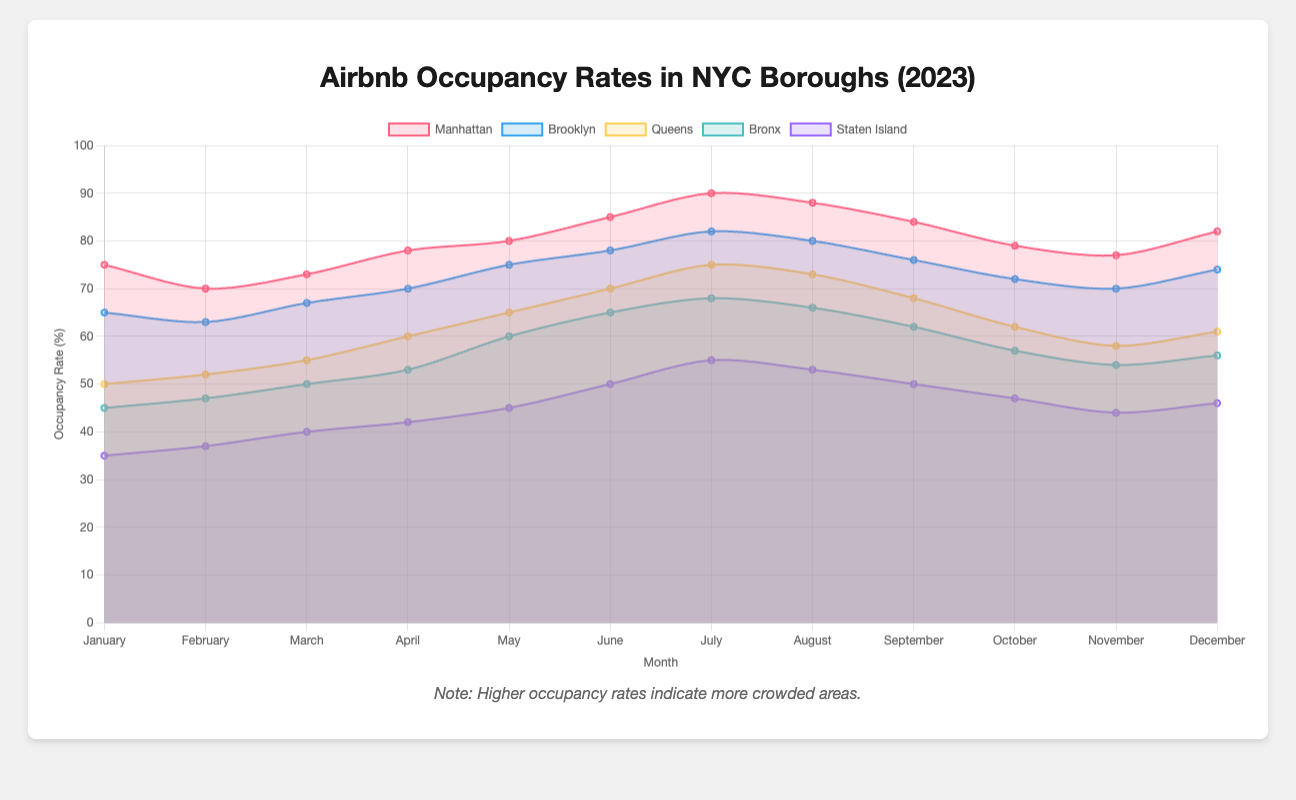What is the title of the chart? The title of the chart is usually displayed at the top. Here it is stated as "Airbnb Occupancy Rates in NYC Boroughs (2023)".
Answer: "Airbnb Occupancy Rates in NYC Boroughs (2023)" In which month does Manhattan have the highest occupancy rate? From the data, we can see that Manhattan's occupancy rate is the highest in July at 90%.
Answer: July How do the occupancy rates of Brooklyn in July compare to those in August? Brooklyn's occupancy rate in July is 82%, while in August it is 80%. Therefore, July has a higher occupancy rate.
Answer: July What is the overall trend for Queens' occupancy rates from January to December? The chart shows that Queens' occupancy rates steadily increase from January (50%) to July (75%), then gradually decrease towards December (61%).
Answer: Increasing then decreasing Which borough has the lowest average occupancy rate over the year? To find the average occupancy rate for each borough over the year, sum the monthly rates and divide by 12. The borough with the lowest sum/average rate will be the answer. Here, Staten Island has the lowest rates, so it will likely have the lowest average. Sum all rates for Staten Island (35, 37, 40, 42, 45, 50, 55, 53, 50, 47, 44, 46) which total 544, then divide by 12 to get the average which is around 45.33.
Answer: Staten Island Which borough has the highest increase in occupancy rate between January and July? By comparing the occupancy rates in January and July for each borough, we see the differences:
- Manhattan: 90 - 75 = 15
- Brooklyn: 82 - 65 = 17
- Queens: 75 - 50 = 25
- Bronx: 68 - 45 = 23
- Staten Island: 55 - 35 = 20
Queens has the highest increase (from 50% to 75%), which is 25%.
Answer: Queens In which month does the Bronx experience the lowest occupancy rate? From the data for the Bronx, the lowest occupancy rate is in January at 45%.
Answer: January Which borough has the smallest variation in occupancy rates over the year? By comparing the range (difference between max and min) of occupancy rates for each borough:
- Manhattan: 90 - 70 = 20
- Brooklyn: 82 - 63 = 19
- Queens: 75 - 50 = 25
- Bronx: 68 - 45 = 23
- Staten Island: 55 - 35 = 20
Brooklyn has the smallest variation, with a range of 19%.
Answer: Brooklyn How do the occupancy rates in Staten Island for May and June compare? From the data, Staten Island has an occupancy rate of 45% in May and 50% in June. Therefore, June has a higher occupancy rate.
Answer: June 